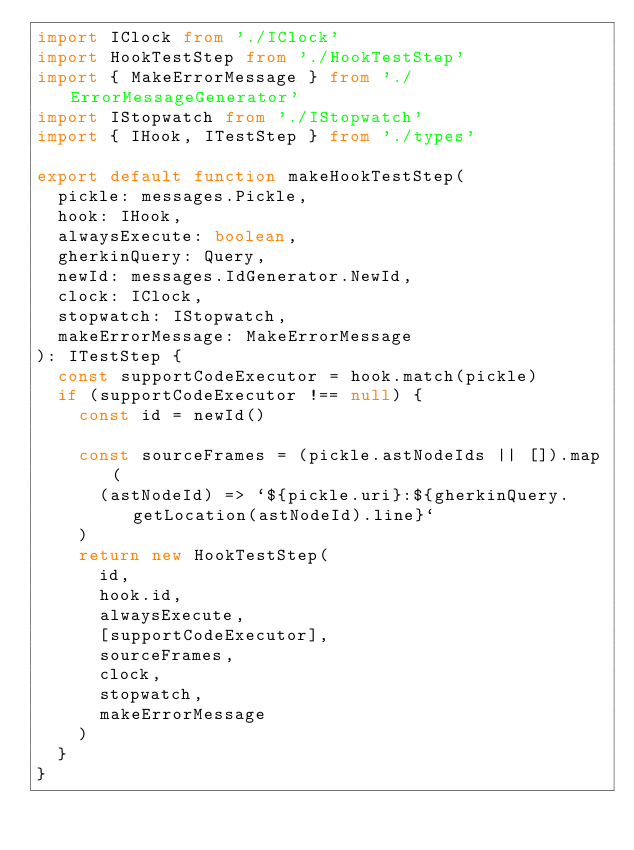<code> <loc_0><loc_0><loc_500><loc_500><_TypeScript_>import IClock from './IClock'
import HookTestStep from './HookTestStep'
import { MakeErrorMessage } from './ErrorMessageGenerator'
import IStopwatch from './IStopwatch'
import { IHook, ITestStep } from './types'

export default function makeHookTestStep(
  pickle: messages.Pickle,
  hook: IHook,
  alwaysExecute: boolean,
  gherkinQuery: Query,
  newId: messages.IdGenerator.NewId,
  clock: IClock,
  stopwatch: IStopwatch,
  makeErrorMessage: MakeErrorMessage
): ITestStep {
  const supportCodeExecutor = hook.match(pickle)
  if (supportCodeExecutor !== null) {
    const id = newId()

    const sourceFrames = (pickle.astNodeIds || []).map(
      (astNodeId) => `${pickle.uri}:${gherkinQuery.getLocation(astNodeId).line}`
    )
    return new HookTestStep(
      id,
      hook.id,
      alwaysExecute,
      [supportCodeExecutor],
      sourceFrames,
      clock,
      stopwatch,
      makeErrorMessage
    )
  }
}
</code> 